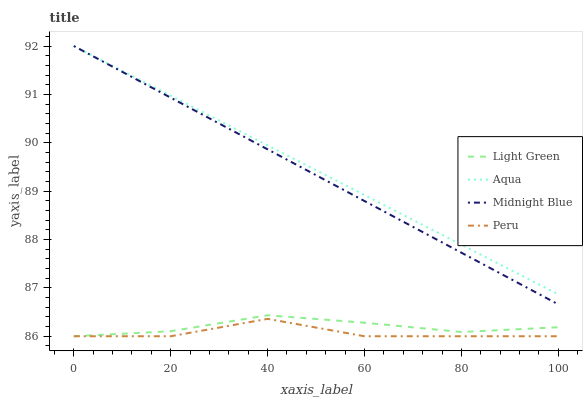Does Peru have the minimum area under the curve?
Answer yes or no. Yes. Does Aqua have the maximum area under the curve?
Answer yes or no. Yes. Does Midnight Blue have the minimum area under the curve?
Answer yes or no. No. Does Midnight Blue have the maximum area under the curve?
Answer yes or no. No. Is Midnight Blue the smoothest?
Answer yes or no. Yes. Is Peru the roughest?
Answer yes or no. Yes. Is Aqua the smoothest?
Answer yes or no. No. Is Aqua the roughest?
Answer yes or no. No. Does Peru have the lowest value?
Answer yes or no. Yes. Does Midnight Blue have the lowest value?
Answer yes or no. No. Does Midnight Blue have the highest value?
Answer yes or no. Yes. Does Light Green have the highest value?
Answer yes or no. No. Is Peru less than Midnight Blue?
Answer yes or no. Yes. Is Aqua greater than Light Green?
Answer yes or no. Yes. Does Midnight Blue intersect Aqua?
Answer yes or no. Yes. Is Midnight Blue less than Aqua?
Answer yes or no. No. Is Midnight Blue greater than Aqua?
Answer yes or no. No. Does Peru intersect Midnight Blue?
Answer yes or no. No. 